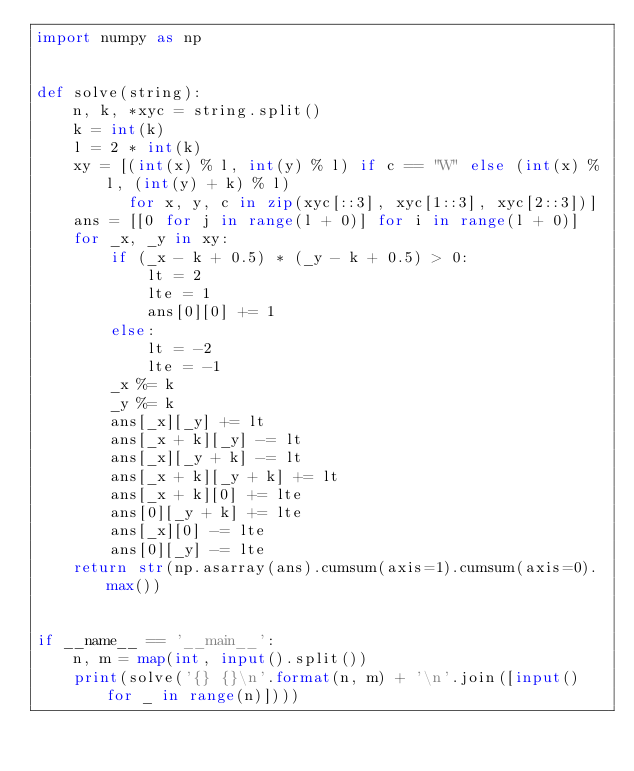Convert code to text. <code><loc_0><loc_0><loc_500><loc_500><_Python_>import numpy as np


def solve(string):
    n, k, *xyc = string.split()
    k = int(k)
    l = 2 * int(k)
    xy = [(int(x) % l, int(y) % l) if c == "W" else (int(x) % l, (int(y) + k) % l)
          for x, y, c in zip(xyc[::3], xyc[1::3], xyc[2::3])]
    ans = [[0 for j in range(l + 0)] for i in range(l + 0)]
    for _x, _y in xy:
        if (_x - k + 0.5) * (_y - k + 0.5) > 0:
            lt = 2
            lte = 1
            ans[0][0] += 1
        else:
            lt = -2
            lte = -1
        _x %= k
        _y %= k
        ans[_x][_y] += lt
        ans[_x + k][_y] -= lt
        ans[_x][_y + k] -= lt
        ans[_x + k][_y + k] += lt
        ans[_x + k][0] += lte
        ans[0][_y + k] += lte
        ans[_x][0] -= lte
        ans[0][_y] -= lte
    return str(np.asarray(ans).cumsum(axis=1).cumsum(axis=0).max())


if __name__ == '__main__':
    n, m = map(int, input().split())
    print(solve('{} {}\n'.format(n, m) + '\n'.join([input() for _ in range(n)])))
</code> 